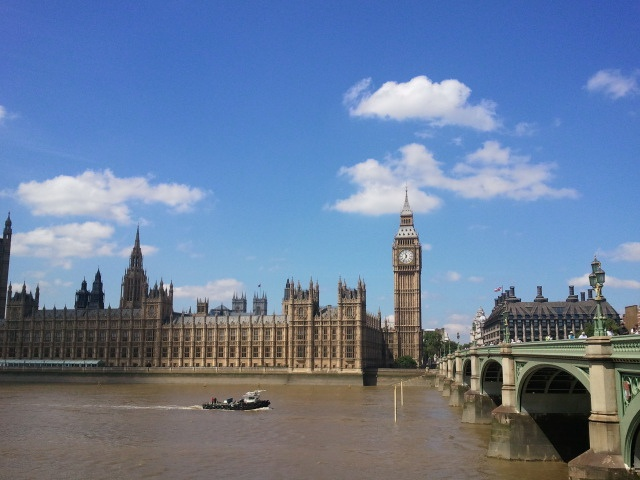Describe the objects in this image and their specific colors. I can see boat in blue, black, gray, and darkgray tones, clock in blue, darkgray, lightgray, and gray tones, people in blue, black, and gray tones, people in blue, black, darkgray, lightgray, and gray tones, and people in blue, gray, darkgray, and black tones in this image. 